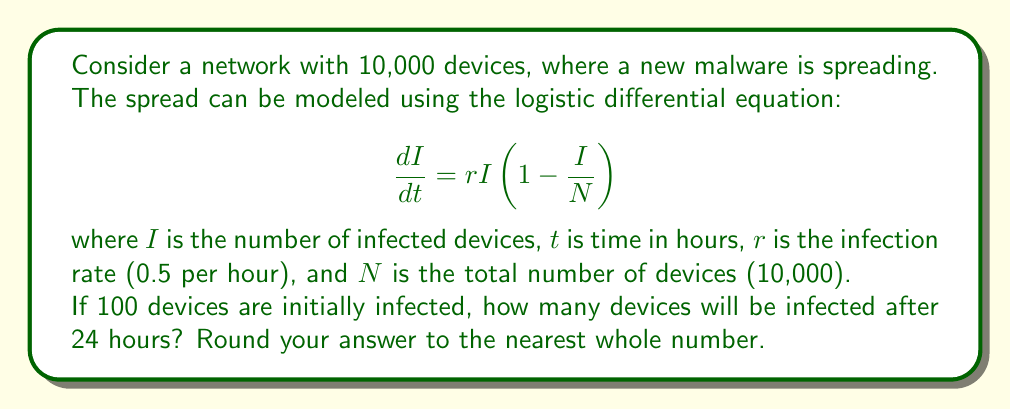Could you help me with this problem? To solve this problem, we need to integrate the logistic differential equation and apply the given initial conditions. Here's a step-by-step approach:

1) The general solution to the logistic differential equation is:

   $$I(t) = \frac{N}{1 + Ce^{-rt}}$$

   where $C$ is a constant determined by the initial conditions.

2) Given:
   - $N = 10,000$ (total devices)
   - $r = 0.5$ (infection rate per hour)
   - $I(0) = 100$ (initially infected devices)
   - We need to find $I(24)$

3) To find $C$, we use the initial condition $I(0) = 100$:

   $$100 = \frac{10000}{1 + C}$$

   Solving for $C$:
   $$C = \frac{10000}{100} - 1 = 99$$

4) Now we can write the full solution:

   $$I(t) = \frac{10000}{1 + 99e^{-0.5t}}$$

5) To find the number of infected devices after 24 hours, we calculate $I(24)$:

   $$I(24) = \frac{10000}{1 + 99e^{-0.5(24)}}$$

6) Simplifying:
   $$I(24) = \frac{10000}{1 + 99e^{-12}} \approx 9999.99$$

7) Rounding to the nearest whole number:
   $I(24) \approx 10000$

This result indicates that after 24 hours, practically all devices in the network will be infected by the malware.
Answer: 10000 devices 